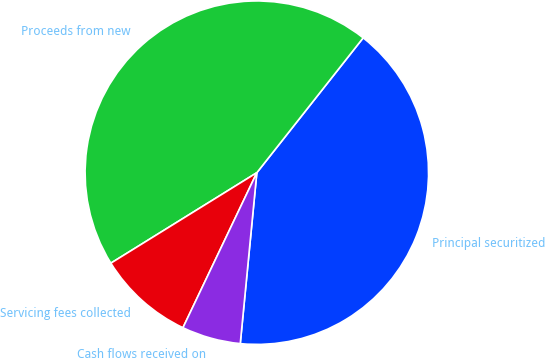<chart> <loc_0><loc_0><loc_500><loc_500><pie_chart><fcel>Principal securitized<fcel>Proceeds from new<fcel>Servicing fees collected<fcel>Cash flows received on<nl><fcel>40.91%<fcel>44.46%<fcel>9.09%<fcel>5.54%<nl></chart> 